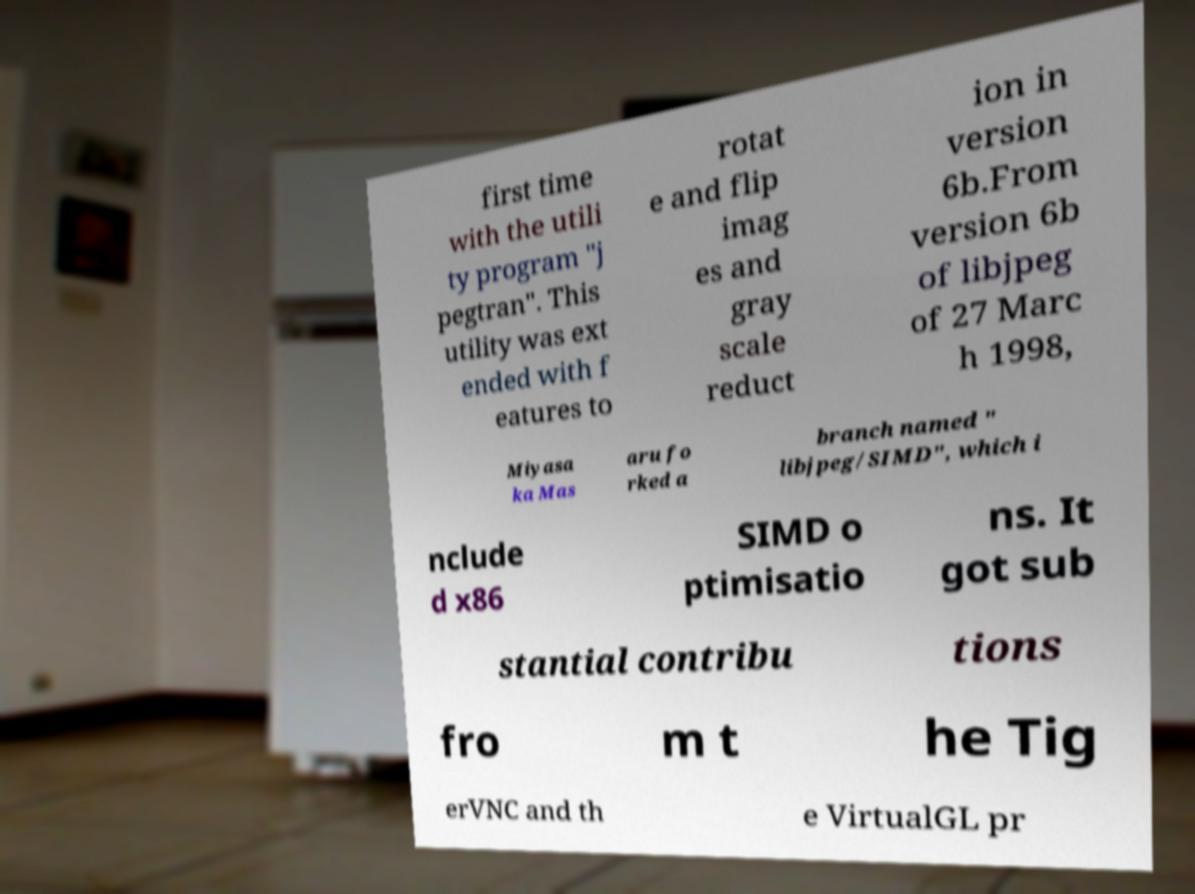Could you extract and type out the text from this image? first time with the utili ty program "j pegtran". This utility was ext ended with f eatures to rotat e and flip imag es and gray scale reduct ion in version 6b.From version 6b of libjpeg of 27 Marc h 1998, Miyasa ka Mas aru fo rked a branch named " libjpeg/SIMD", which i nclude d x86 SIMD o ptimisatio ns. It got sub stantial contribu tions fro m t he Tig erVNC and th e VirtualGL pr 